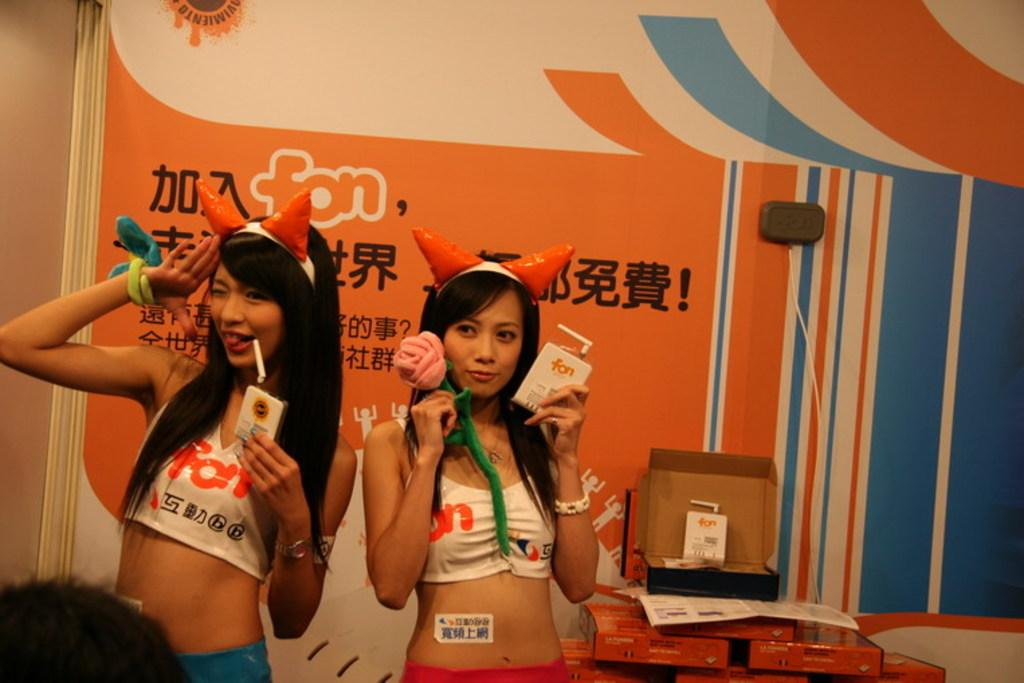How many girls are in the image? There are two girls in the image. Where are the girls located in the image? The girls are on the left side of the image. What can be seen on the right side of the image? There are boxes on the right side of the image. What is visible in the background of the image? There is a poster in the background of the image. What type of clouds can be seen in the image? There are no clouds visible in the image. Can you describe the elbow of the girl on the left side of the image? The image does not provide a clear view of the girls' elbows, so it is not possible to describe them. 